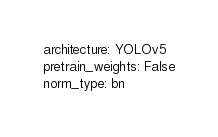Convert code to text. <code><loc_0><loc_0><loc_500><loc_500><_YAML_>architecture: YOLOv5
pretrain_weights: False
norm_type: bn
</code> 